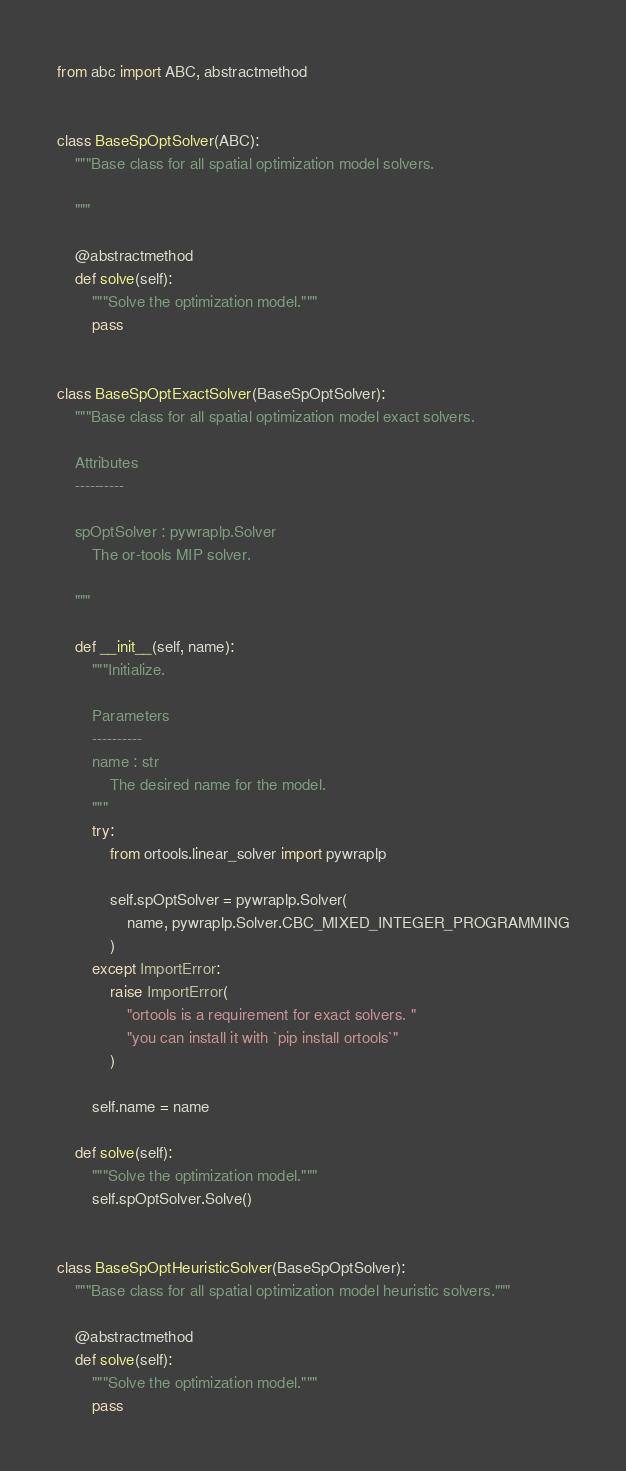<code> <loc_0><loc_0><loc_500><loc_500><_Python_>from abc import ABC, abstractmethod


class BaseSpOptSolver(ABC):
    """Base class for all spatial optimization model solvers.

    """

    @abstractmethod
    def solve(self):
        """Solve the optimization model."""
        pass


class BaseSpOptExactSolver(BaseSpOptSolver):
    """Base class for all spatial optimization model exact solvers.

    Attributes
    ----------

    spOptSolver : pywraplp.Solver
        The or-tools MIP solver.

    """

    def __init__(self, name):
        """Initialize.

        Parameters
        ----------
        name : str
            The desired name for the model.
        """
        try:
            from ortools.linear_solver import pywraplp

            self.spOptSolver = pywraplp.Solver(
                name, pywraplp.Solver.CBC_MIXED_INTEGER_PROGRAMMING
            )
        except ImportError:
            raise ImportError(
                "ortools is a requirement for exact solvers. "
                "you can install it with `pip install ortools`"
            )

        self.name = name

    def solve(self):
        """Solve the optimization model."""
        self.spOptSolver.Solve()


class BaseSpOptHeuristicSolver(BaseSpOptSolver):
    """Base class for all spatial optimization model heuristic solvers."""

    @abstractmethod
    def solve(self):
        """Solve the optimization model."""
        pass</code> 